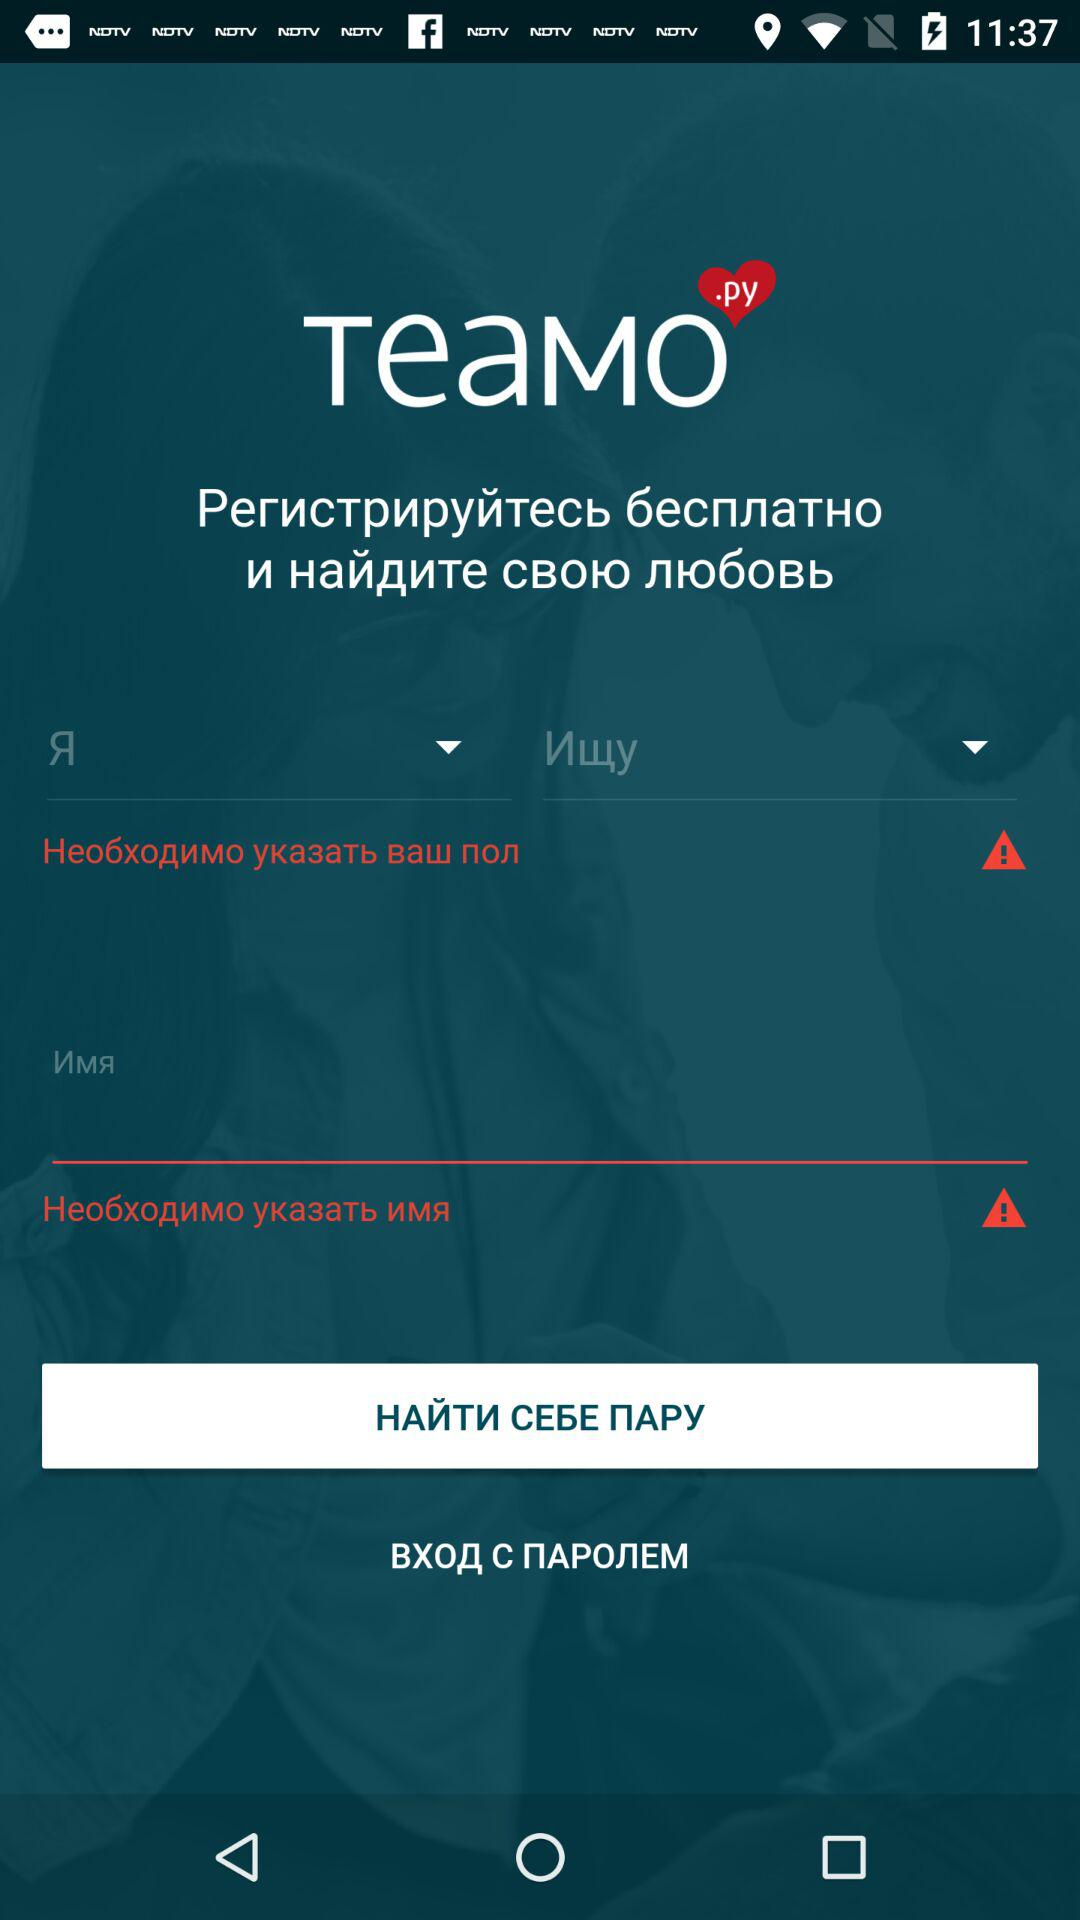How many red triangles with exclamation marks are in the app?
Answer the question using a single word or phrase. 2 